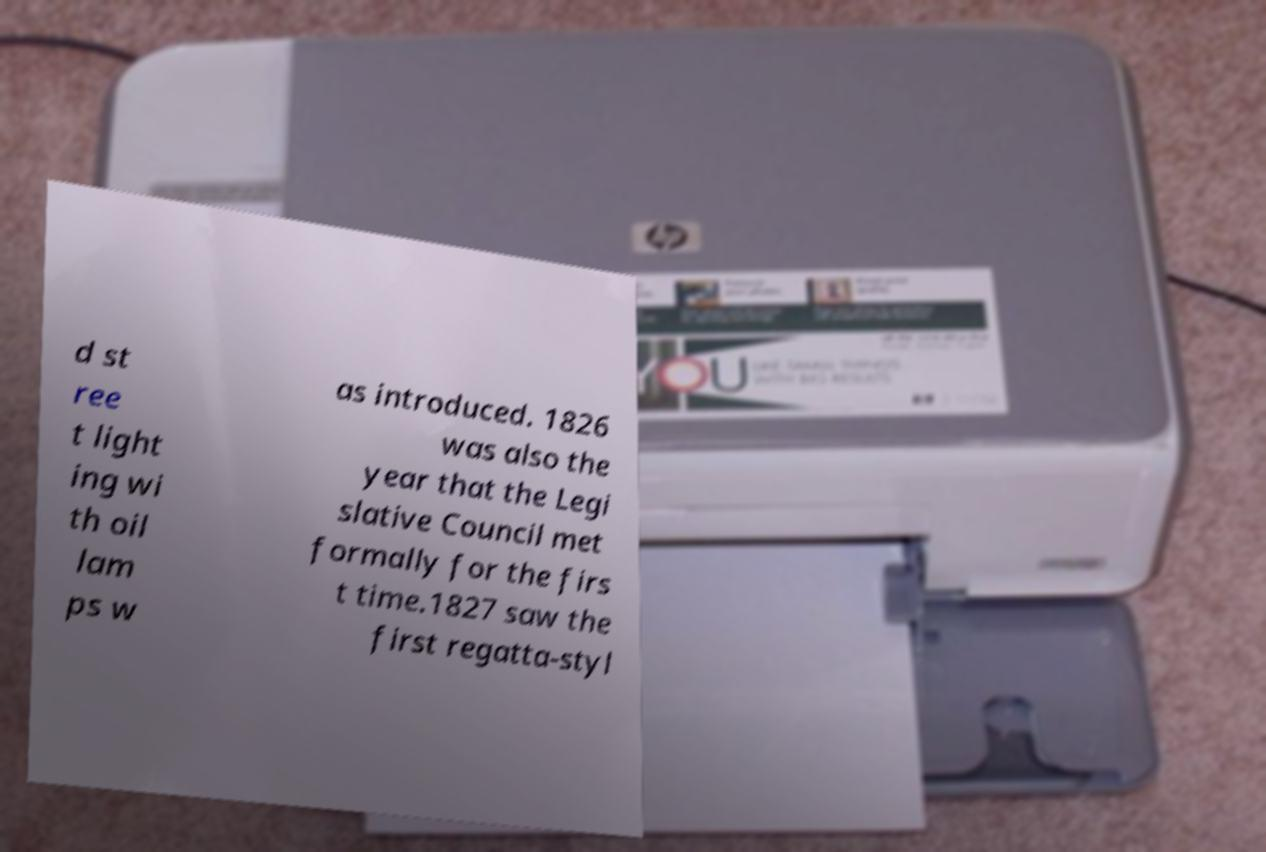Please read and relay the text visible in this image. What does it say? d st ree t light ing wi th oil lam ps w as introduced. 1826 was also the year that the Legi slative Council met formally for the firs t time.1827 saw the first regatta-styl 